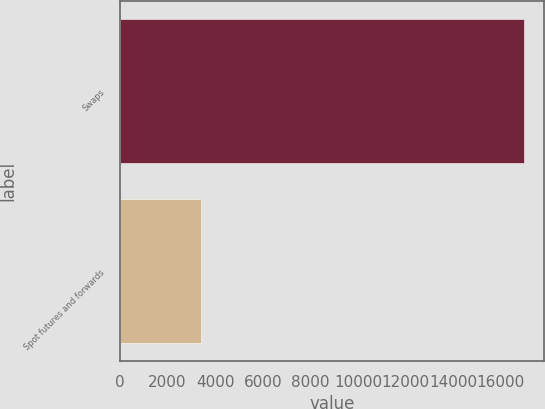Convert chart to OTSL. <chart><loc_0><loc_0><loc_500><loc_500><bar_chart><fcel>Swaps<fcel>Spot futures and forwards<nl><fcel>16977.7<fcel>3410.7<nl></chart> 